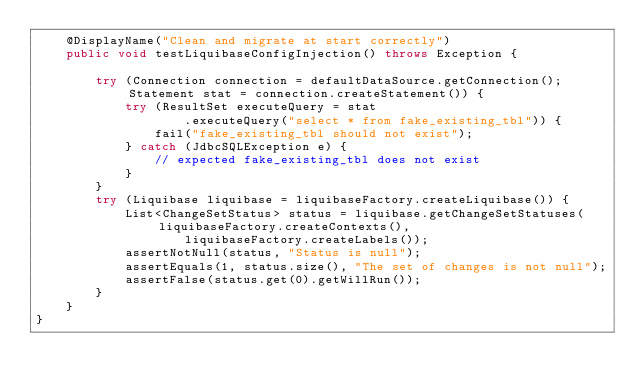<code> <loc_0><loc_0><loc_500><loc_500><_Java_>    @DisplayName("Clean and migrate at start correctly")
    public void testLiquibaseConfigInjection() throws Exception {

        try (Connection connection = defaultDataSource.getConnection(); Statement stat = connection.createStatement()) {
            try (ResultSet executeQuery = stat
                    .executeQuery("select * from fake_existing_tbl")) {
                fail("fake_existing_tbl should not exist");
            } catch (JdbcSQLException e) {
                // expected fake_existing_tbl does not exist
            }
        }
        try (Liquibase liquibase = liquibaseFactory.createLiquibase()) {
            List<ChangeSetStatus> status = liquibase.getChangeSetStatuses(liquibaseFactory.createContexts(),
                    liquibaseFactory.createLabels());
            assertNotNull(status, "Status is null");
            assertEquals(1, status.size(), "The set of changes is not null");
            assertFalse(status.get(0).getWillRun());
        }
    }
}
</code> 